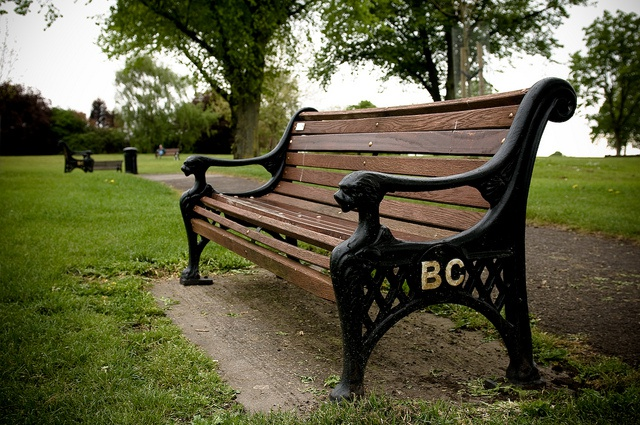Describe the objects in this image and their specific colors. I can see bench in gray, black, and olive tones, bench in gray, black, and olive tones, bench in gray, darkgreen, and black tones, bench in gray, olive, and black tones, and people in gray and black tones in this image. 